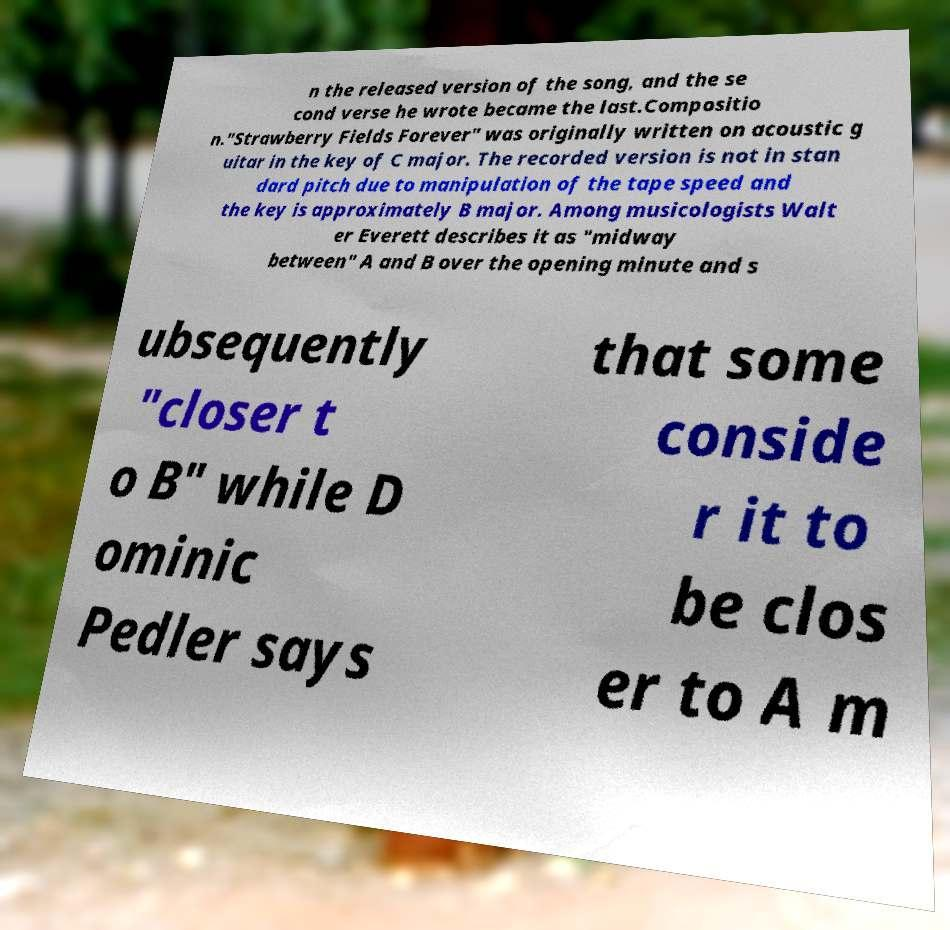Please read and relay the text visible in this image. What does it say? n the released version of the song, and the se cond verse he wrote became the last.Compositio n."Strawberry Fields Forever" was originally written on acoustic g uitar in the key of C major. The recorded version is not in stan dard pitch due to manipulation of the tape speed and the key is approximately B major. Among musicologists Walt er Everett describes it as "midway between" A and B over the opening minute and s ubsequently "closer t o B" while D ominic Pedler says that some conside r it to be clos er to A m 